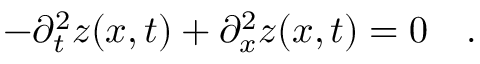Convert formula to latex. <formula><loc_0><loc_0><loc_500><loc_500>- \partial _ { t } ^ { 2 } z ( x , t ) + \partial _ { x } ^ { 2 } z ( x , t ) = 0 \quad .</formula> 